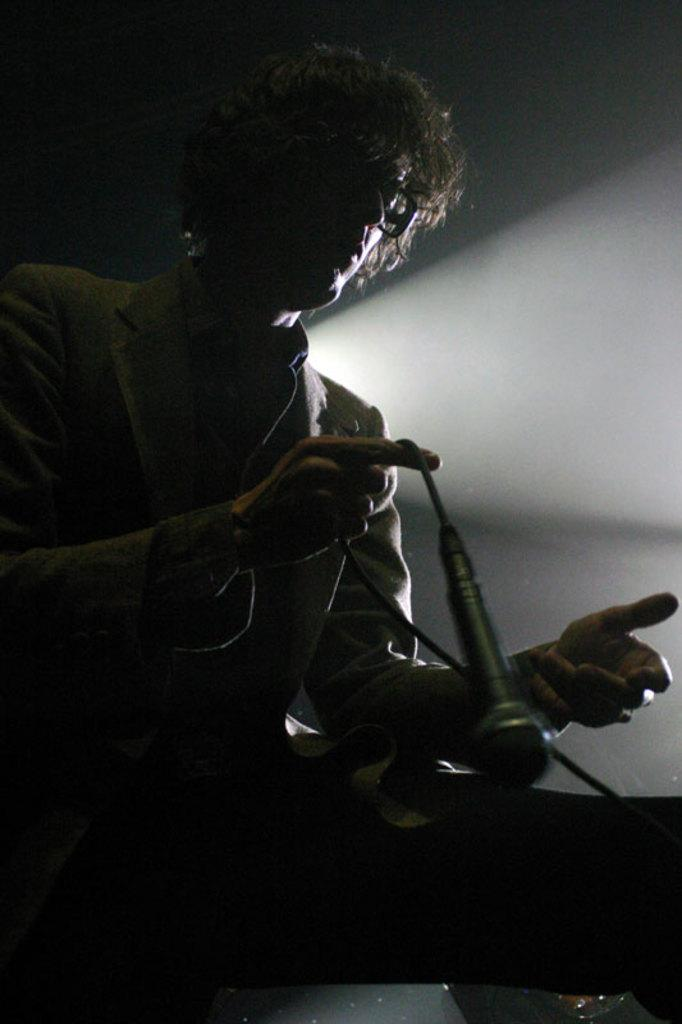Who is the main subject in the image? There is a man in the image. What is the man holding in the image? The man is holding a microphone. What can be observed about the background of the image? The background of the image is dark. What type of attraction can be seen in the background of the image? There is no attraction visible in the background of the image; it is dark. 